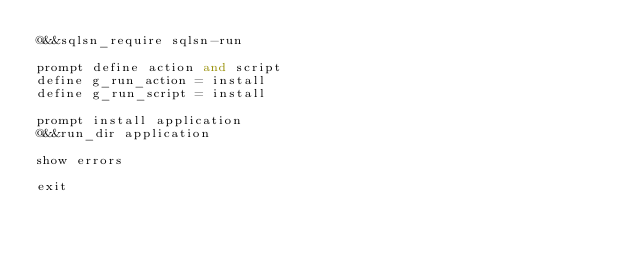Convert code to text. <code><loc_0><loc_0><loc_500><loc_500><_SQL_>@&&sqlsn_require sqlsn-run

prompt define action and script
define g_run_action = install
define g_run_script = install

prompt install application
@&&run_dir application

show errors

exit</code> 